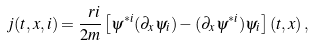<formula> <loc_0><loc_0><loc_500><loc_500>j ( t , x , i ) = \frac { \ r i } { 2 m } \left [ \psi ^ { * i } ( \partial _ { x } \psi _ { i } ) - ( \partial _ { x } \psi ^ { * i } ) \psi _ { i } \right ] ( t , x ) \, ,</formula> 